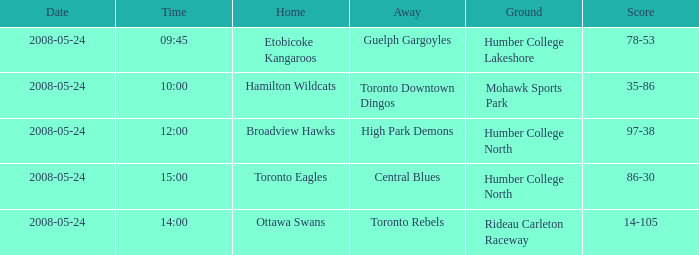Who was the home team of the game at the time of 15:00? Toronto Eagles. 